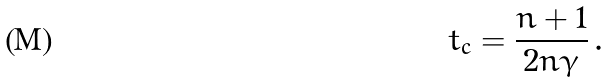Convert formula to latex. <formula><loc_0><loc_0><loc_500><loc_500>t _ { c } = \frac { n + 1 } { 2 n \gamma } \, .</formula> 